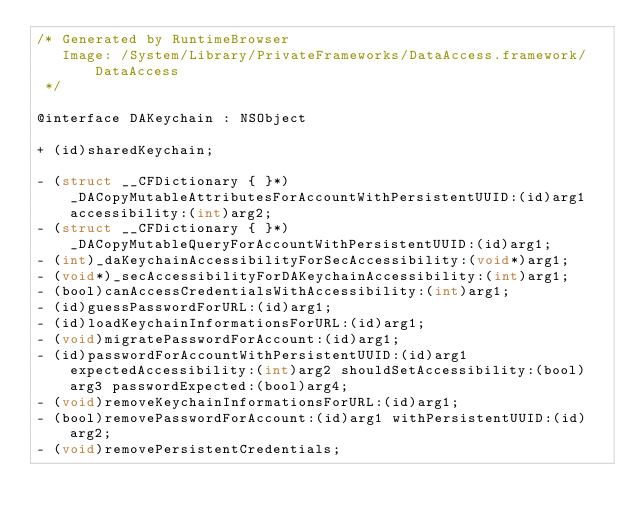Convert code to text. <code><loc_0><loc_0><loc_500><loc_500><_C_>/* Generated by RuntimeBrowser
   Image: /System/Library/PrivateFrameworks/DataAccess.framework/DataAccess
 */

@interface DAKeychain : NSObject

+ (id)sharedKeychain;

- (struct __CFDictionary { }*)_DACopyMutableAttributesForAccountWithPersistentUUID:(id)arg1 accessibility:(int)arg2;
- (struct __CFDictionary { }*)_DACopyMutableQueryForAccountWithPersistentUUID:(id)arg1;
- (int)_daKeychainAccessibilityForSecAccessibility:(void*)arg1;
- (void*)_secAccessibilityForDAKeychainAccessibility:(int)arg1;
- (bool)canAccessCredentialsWithAccessibility:(int)arg1;
- (id)guessPasswordForURL:(id)arg1;
- (id)loadKeychainInformationsForURL:(id)arg1;
- (void)migratePasswordForAccount:(id)arg1;
- (id)passwordForAccountWithPersistentUUID:(id)arg1 expectedAccessibility:(int)arg2 shouldSetAccessibility:(bool)arg3 passwordExpected:(bool)arg4;
- (void)removeKeychainInformationsForURL:(id)arg1;
- (bool)removePasswordForAccount:(id)arg1 withPersistentUUID:(id)arg2;
- (void)removePersistentCredentials;</code> 